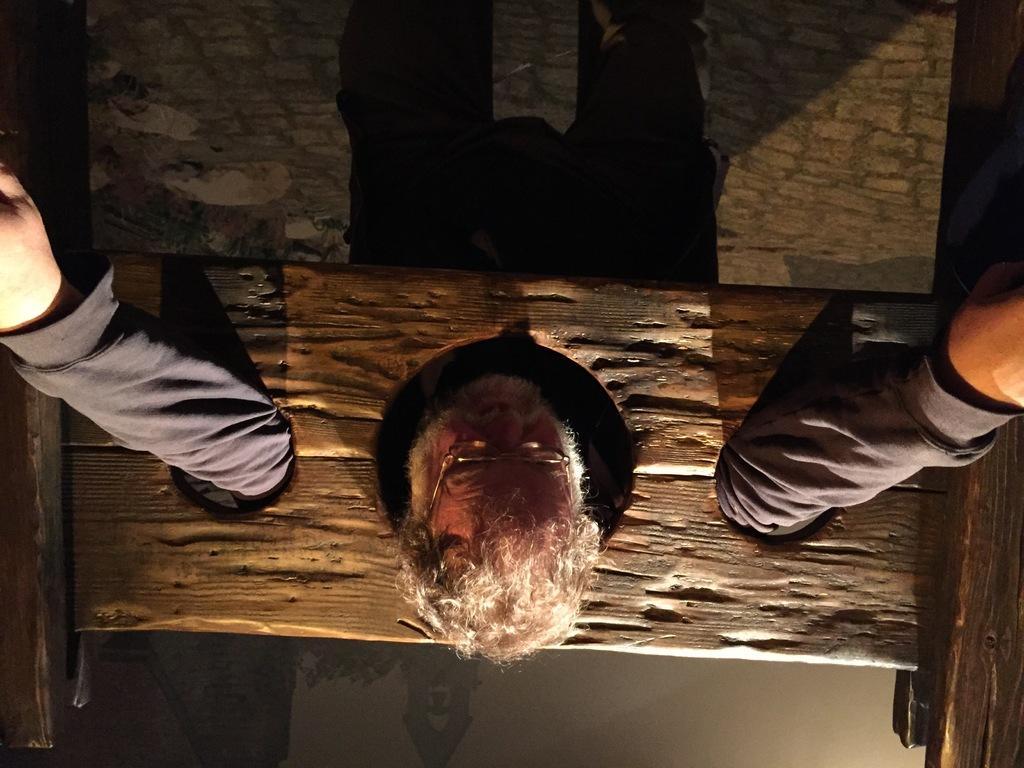Describe this image in one or two sentences. In the picture I can see a man in middle of the image. He is wearing clothes and spectacles and I can see the hand of a man are kept out from the wooden block as it is having two holes. 